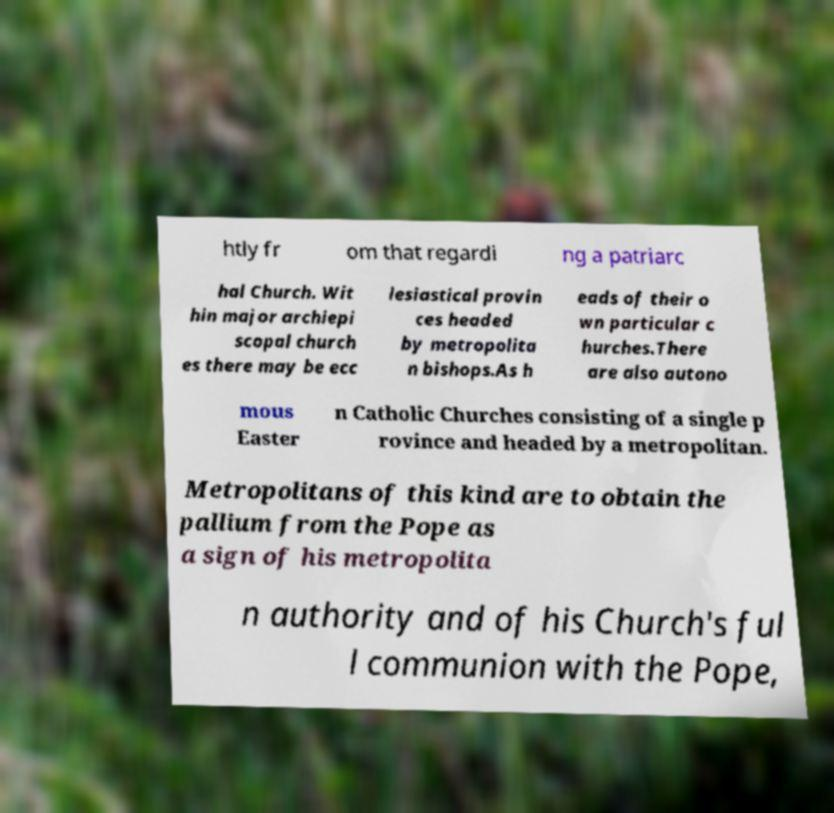Please identify and transcribe the text found in this image. htly fr om that regardi ng a patriarc hal Church. Wit hin major archiepi scopal church es there may be ecc lesiastical provin ces headed by metropolita n bishops.As h eads of their o wn particular c hurches.There are also autono mous Easter n Catholic Churches consisting of a single p rovince and headed by a metropolitan. Metropolitans of this kind are to obtain the pallium from the Pope as a sign of his metropolita n authority and of his Church's ful l communion with the Pope, 